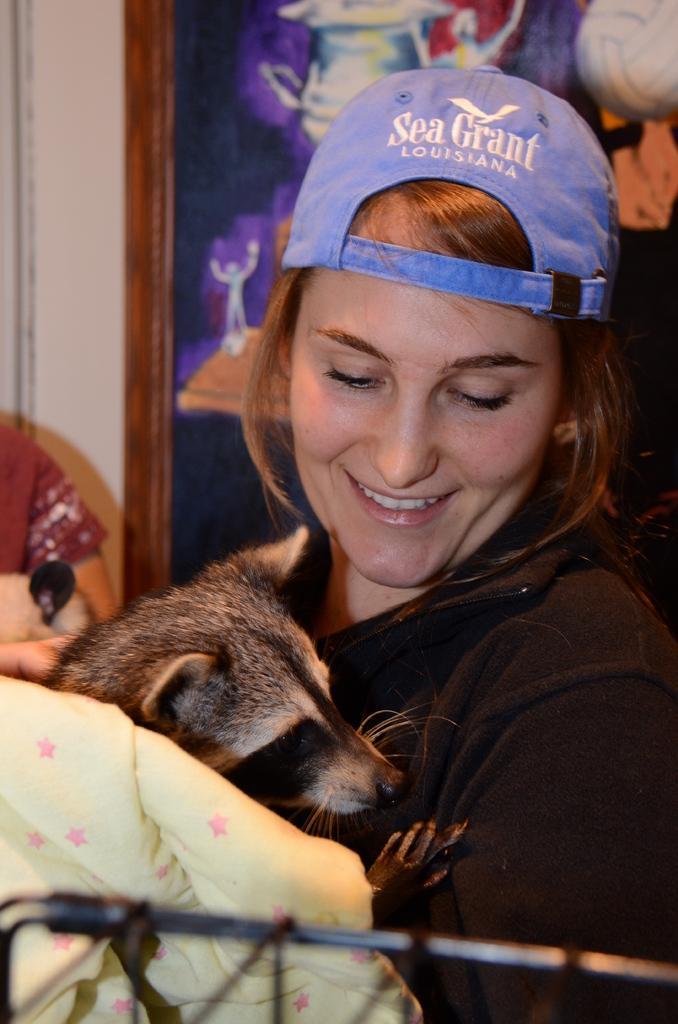Could you give a brief overview of what you see in this image? In this image I can see a woman wearing a blue hat is holding an animal. 